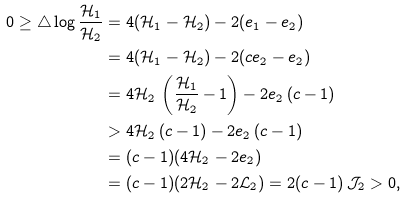Convert formula to latex. <formula><loc_0><loc_0><loc_500><loc_500>0 \geq \mathcal { 4 } \log \frac { \mathcal { H } _ { 1 } } { \mathcal { H } _ { 2 } } & = 4 ( \mathcal { H } _ { 1 } - \mathcal { H } _ { 2 } ) - 2 ( e _ { 1 } - e _ { 2 } ) \\ & = 4 ( \mathcal { H } _ { 1 } - \mathcal { H } _ { 2 } ) - 2 ( c e _ { 2 } - e _ { 2 } ) \\ & = 4 \mathcal { H } _ { 2 } \, \left ( \frac { \mathcal { H } _ { 1 } } { \mathcal { H } _ { 2 } } - 1 \right ) - 2 e _ { 2 } \, ( c - 1 ) \\ & > 4 \mathcal { H } _ { 2 } \, ( c - 1 ) - 2 e _ { 2 } \, ( c - 1 ) \\ & = ( c - 1 ) ( 4 \mathcal { H } _ { 2 } - 2 e _ { 2 } ) \\ & = ( c - 1 ) ( 2 \mathcal { H } _ { 2 } - 2 \mathcal { L } _ { 2 } ) = 2 ( c - 1 ) \, \mathcal { J } _ { 2 } > 0 ,</formula> 